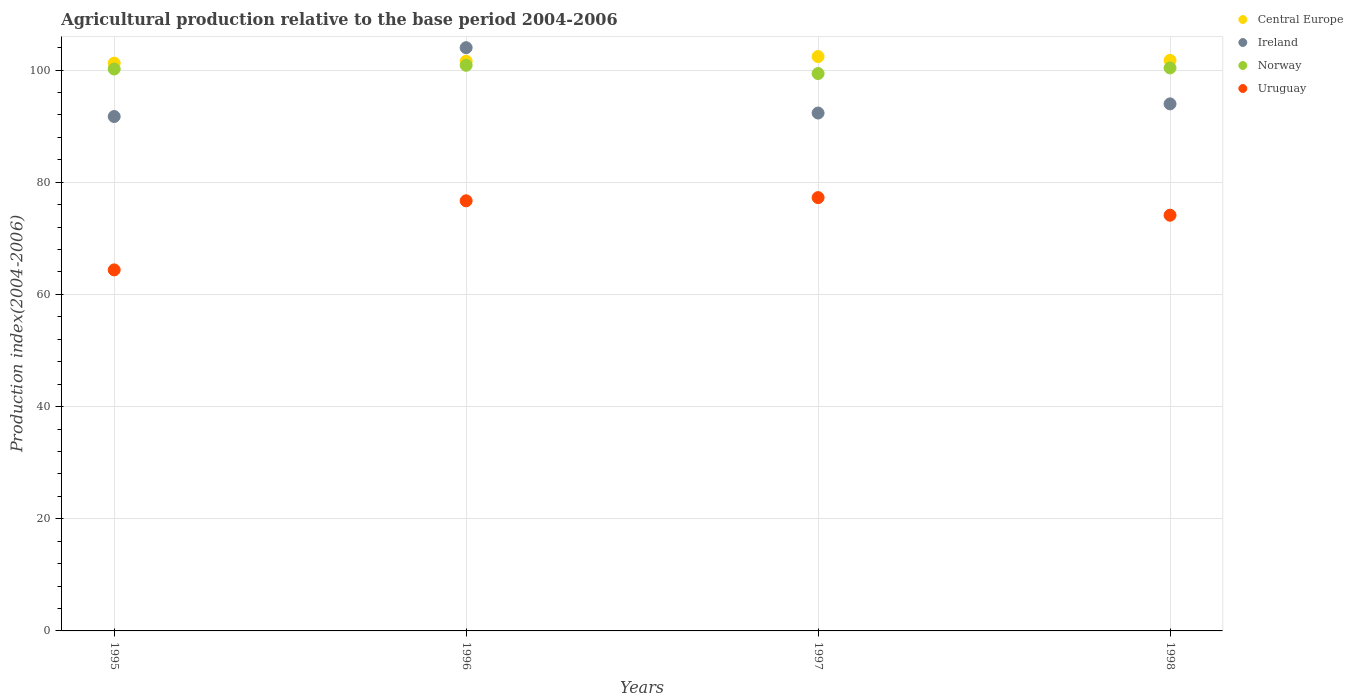Is the number of dotlines equal to the number of legend labels?
Give a very brief answer. Yes. What is the agricultural production index in Ireland in 1995?
Keep it short and to the point. 91.72. Across all years, what is the maximum agricultural production index in Uruguay?
Offer a terse response. 77.26. Across all years, what is the minimum agricultural production index in Uruguay?
Provide a succinct answer. 64.37. In which year was the agricultural production index in Norway maximum?
Your response must be concise. 1996. What is the total agricultural production index in Uruguay in the graph?
Your answer should be compact. 292.44. What is the difference between the agricultural production index in Ireland in 1997 and that in 1998?
Keep it short and to the point. -1.63. What is the difference between the agricultural production index in Ireland in 1998 and the agricultural production index in Uruguay in 1997?
Your answer should be compact. 16.71. What is the average agricultural production index in Central Europe per year?
Make the answer very short. 101.74. In the year 1995, what is the difference between the agricultural production index in Uruguay and agricultural production index in Central Europe?
Provide a short and direct response. -36.86. In how many years, is the agricultural production index in Central Europe greater than 44?
Provide a succinct answer. 4. What is the ratio of the agricultural production index in Uruguay in 1996 to that in 1997?
Your answer should be compact. 0.99. What is the difference between the highest and the second highest agricultural production index in Ireland?
Offer a very short reply. 10.02. What is the difference between the highest and the lowest agricultural production index in Norway?
Give a very brief answer. 1.47. In how many years, is the agricultural production index in Uruguay greater than the average agricultural production index in Uruguay taken over all years?
Give a very brief answer. 3. Does the agricultural production index in Norway monotonically increase over the years?
Your answer should be very brief. No. Is the agricultural production index in Norway strictly greater than the agricultural production index in Ireland over the years?
Ensure brevity in your answer.  No. How many dotlines are there?
Provide a succinct answer. 4. What is the difference between two consecutive major ticks on the Y-axis?
Your answer should be compact. 20. Does the graph contain any zero values?
Offer a very short reply. No. Does the graph contain grids?
Provide a succinct answer. Yes. Where does the legend appear in the graph?
Give a very brief answer. Top right. How are the legend labels stacked?
Your response must be concise. Vertical. What is the title of the graph?
Provide a short and direct response. Agricultural production relative to the base period 2004-2006. Does "Finland" appear as one of the legend labels in the graph?
Make the answer very short. No. What is the label or title of the Y-axis?
Offer a terse response. Production index(2004-2006). What is the Production index(2004-2006) in Central Europe in 1995?
Ensure brevity in your answer.  101.23. What is the Production index(2004-2006) of Ireland in 1995?
Keep it short and to the point. 91.72. What is the Production index(2004-2006) in Norway in 1995?
Provide a short and direct response. 100.19. What is the Production index(2004-2006) in Uruguay in 1995?
Your answer should be compact. 64.37. What is the Production index(2004-2006) of Central Europe in 1996?
Offer a very short reply. 101.58. What is the Production index(2004-2006) in Ireland in 1996?
Keep it short and to the point. 103.99. What is the Production index(2004-2006) of Norway in 1996?
Make the answer very short. 100.85. What is the Production index(2004-2006) of Uruguay in 1996?
Make the answer very short. 76.69. What is the Production index(2004-2006) in Central Europe in 1997?
Keep it short and to the point. 102.41. What is the Production index(2004-2006) of Ireland in 1997?
Your answer should be compact. 92.34. What is the Production index(2004-2006) of Norway in 1997?
Offer a terse response. 99.38. What is the Production index(2004-2006) in Uruguay in 1997?
Offer a very short reply. 77.26. What is the Production index(2004-2006) of Central Europe in 1998?
Keep it short and to the point. 101.72. What is the Production index(2004-2006) of Ireland in 1998?
Give a very brief answer. 93.97. What is the Production index(2004-2006) of Norway in 1998?
Your response must be concise. 100.38. What is the Production index(2004-2006) of Uruguay in 1998?
Keep it short and to the point. 74.12. Across all years, what is the maximum Production index(2004-2006) of Central Europe?
Your response must be concise. 102.41. Across all years, what is the maximum Production index(2004-2006) in Ireland?
Your response must be concise. 103.99. Across all years, what is the maximum Production index(2004-2006) in Norway?
Provide a succinct answer. 100.85. Across all years, what is the maximum Production index(2004-2006) in Uruguay?
Your response must be concise. 77.26. Across all years, what is the minimum Production index(2004-2006) in Central Europe?
Keep it short and to the point. 101.23. Across all years, what is the minimum Production index(2004-2006) in Ireland?
Offer a terse response. 91.72. Across all years, what is the minimum Production index(2004-2006) of Norway?
Give a very brief answer. 99.38. Across all years, what is the minimum Production index(2004-2006) of Uruguay?
Provide a succinct answer. 64.37. What is the total Production index(2004-2006) in Central Europe in the graph?
Provide a short and direct response. 406.95. What is the total Production index(2004-2006) of Ireland in the graph?
Keep it short and to the point. 382.02. What is the total Production index(2004-2006) in Norway in the graph?
Offer a very short reply. 400.8. What is the total Production index(2004-2006) in Uruguay in the graph?
Your response must be concise. 292.44. What is the difference between the Production index(2004-2006) of Central Europe in 1995 and that in 1996?
Your answer should be compact. -0.35. What is the difference between the Production index(2004-2006) of Ireland in 1995 and that in 1996?
Give a very brief answer. -12.27. What is the difference between the Production index(2004-2006) of Norway in 1995 and that in 1996?
Your answer should be compact. -0.66. What is the difference between the Production index(2004-2006) of Uruguay in 1995 and that in 1996?
Make the answer very short. -12.32. What is the difference between the Production index(2004-2006) in Central Europe in 1995 and that in 1997?
Your response must be concise. -1.18. What is the difference between the Production index(2004-2006) of Ireland in 1995 and that in 1997?
Offer a very short reply. -0.62. What is the difference between the Production index(2004-2006) of Norway in 1995 and that in 1997?
Give a very brief answer. 0.81. What is the difference between the Production index(2004-2006) of Uruguay in 1995 and that in 1997?
Offer a terse response. -12.89. What is the difference between the Production index(2004-2006) in Central Europe in 1995 and that in 1998?
Give a very brief answer. -0.49. What is the difference between the Production index(2004-2006) of Ireland in 1995 and that in 1998?
Your answer should be compact. -2.25. What is the difference between the Production index(2004-2006) of Norway in 1995 and that in 1998?
Keep it short and to the point. -0.19. What is the difference between the Production index(2004-2006) of Uruguay in 1995 and that in 1998?
Your answer should be very brief. -9.75. What is the difference between the Production index(2004-2006) of Central Europe in 1996 and that in 1997?
Your answer should be compact. -0.83. What is the difference between the Production index(2004-2006) of Ireland in 1996 and that in 1997?
Make the answer very short. 11.65. What is the difference between the Production index(2004-2006) in Norway in 1996 and that in 1997?
Ensure brevity in your answer.  1.47. What is the difference between the Production index(2004-2006) in Uruguay in 1996 and that in 1997?
Make the answer very short. -0.57. What is the difference between the Production index(2004-2006) of Central Europe in 1996 and that in 1998?
Keep it short and to the point. -0.14. What is the difference between the Production index(2004-2006) of Ireland in 1996 and that in 1998?
Keep it short and to the point. 10.02. What is the difference between the Production index(2004-2006) in Norway in 1996 and that in 1998?
Provide a succinct answer. 0.47. What is the difference between the Production index(2004-2006) in Uruguay in 1996 and that in 1998?
Offer a very short reply. 2.57. What is the difference between the Production index(2004-2006) of Central Europe in 1997 and that in 1998?
Your answer should be compact. 0.69. What is the difference between the Production index(2004-2006) in Ireland in 1997 and that in 1998?
Provide a short and direct response. -1.63. What is the difference between the Production index(2004-2006) of Norway in 1997 and that in 1998?
Keep it short and to the point. -1. What is the difference between the Production index(2004-2006) of Uruguay in 1997 and that in 1998?
Your answer should be compact. 3.14. What is the difference between the Production index(2004-2006) of Central Europe in 1995 and the Production index(2004-2006) of Ireland in 1996?
Offer a terse response. -2.76. What is the difference between the Production index(2004-2006) in Central Europe in 1995 and the Production index(2004-2006) in Norway in 1996?
Your answer should be very brief. 0.38. What is the difference between the Production index(2004-2006) of Central Europe in 1995 and the Production index(2004-2006) of Uruguay in 1996?
Offer a terse response. 24.54. What is the difference between the Production index(2004-2006) in Ireland in 1995 and the Production index(2004-2006) in Norway in 1996?
Give a very brief answer. -9.13. What is the difference between the Production index(2004-2006) in Ireland in 1995 and the Production index(2004-2006) in Uruguay in 1996?
Your answer should be very brief. 15.03. What is the difference between the Production index(2004-2006) of Central Europe in 1995 and the Production index(2004-2006) of Ireland in 1997?
Your answer should be compact. 8.89. What is the difference between the Production index(2004-2006) of Central Europe in 1995 and the Production index(2004-2006) of Norway in 1997?
Your answer should be very brief. 1.85. What is the difference between the Production index(2004-2006) of Central Europe in 1995 and the Production index(2004-2006) of Uruguay in 1997?
Ensure brevity in your answer.  23.97. What is the difference between the Production index(2004-2006) of Ireland in 1995 and the Production index(2004-2006) of Norway in 1997?
Give a very brief answer. -7.66. What is the difference between the Production index(2004-2006) in Ireland in 1995 and the Production index(2004-2006) in Uruguay in 1997?
Offer a very short reply. 14.46. What is the difference between the Production index(2004-2006) in Norway in 1995 and the Production index(2004-2006) in Uruguay in 1997?
Make the answer very short. 22.93. What is the difference between the Production index(2004-2006) in Central Europe in 1995 and the Production index(2004-2006) in Ireland in 1998?
Your answer should be compact. 7.26. What is the difference between the Production index(2004-2006) of Central Europe in 1995 and the Production index(2004-2006) of Norway in 1998?
Your response must be concise. 0.85. What is the difference between the Production index(2004-2006) of Central Europe in 1995 and the Production index(2004-2006) of Uruguay in 1998?
Give a very brief answer. 27.11. What is the difference between the Production index(2004-2006) of Ireland in 1995 and the Production index(2004-2006) of Norway in 1998?
Offer a terse response. -8.66. What is the difference between the Production index(2004-2006) in Norway in 1995 and the Production index(2004-2006) in Uruguay in 1998?
Give a very brief answer. 26.07. What is the difference between the Production index(2004-2006) in Central Europe in 1996 and the Production index(2004-2006) in Ireland in 1997?
Provide a succinct answer. 9.24. What is the difference between the Production index(2004-2006) of Central Europe in 1996 and the Production index(2004-2006) of Norway in 1997?
Your answer should be compact. 2.2. What is the difference between the Production index(2004-2006) in Central Europe in 1996 and the Production index(2004-2006) in Uruguay in 1997?
Offer a very short reply. 24.32. What is the difference between the Production index(2004-2006) of Ireland in 1996 and the Production index(2004-2006) of Norway in 1997?
Keep it short and to the point. 4.61. What is the difference between the Production index(2004-2006) of Ireland in 1996 and the Production index(2004-2006) of Uruguay in 1997?
Make the answer very short. 26.73. What is the difference between the Production index(2004-2006) in Norway in 1996 and the Production index(2004-2006) in Uruguay in 1997?
Your answer should be very brief. 23.59. What is the difference between the Production index(2004-2006) in Central Europe in 1996 and the Production index(2004-2006) in Ireland in 1998?
Offer a terse response. 7.61. What is the difference between the Production index(2004-2006) in Central Europe in 1996 and the Production index(2004-2006) in Norway in 1998?
Provide a succinct answer. 1.2. What is the difference between the Production index(2004-2006) in Central Europe in 1996 and the Production index(2004-2006) in Uruguay in 1998?
Make the answer very short. 27.46. What is the difference between the Production index(2004-2006) of Ireland in 1996 and the Production index(2004-2006) of Norway in 1998?
Your response must be concise. 3.61. What is the difference between the Production index(2004-2006) in Ireland in 1996 and the Production index(2004-2006) in Uruguay in 1998?
Your answer should be compact. 29.87. What is the difference between the Production index(2004-2006) of Norway in 1996 and the Production index(2004-2006) of Uruguay in 1998?
Your answer should be very brief. 26.73. What is the difference between the Production index(2004-2006) in Central Europe in 1997 and the Production index(2004-2006) in Ireland in 1998?
Give a very brief answer. 8.44. What is the difference between the Production index(2004-2006) in Central Europe in 1997 and the Production index(2004-2006) in Norway in 1998?
Make the answer very short. 2.03. What is the difference between the Production index(2004-2006) in Central Europe in 1997 and the Production index(2004-2006) in Uruguay in 1998?
Your response must be concise. 28.29. What is the difference between the Production index(2004-2006) of Ireland in 1997 and the Production index(2004-2006) of Norway in 1998?
Your response must be concise. -8.04. What is the difference between the Production index(2004-2006) in Ireland in 1997 and the Production index(2004-2006) in Uruguay in 1998?
Offer a terse response. 18.22. What is the difference between the Production index(2004-2006) in Norway in 1997 and the Production index(2004-2006) in Uruguay in 1998?
Offer a terse response. 25.26. What is the average Production index(2004-2006) in Central Europe per year?
Offer a very short reply. 101.74. What is the average Production index(2004-2006) in Ireland per year?
Offer a very short reply. 95.5. What is the average Production index(2004-2006) of Norway per year?
Offer a very short reply. 100.2. What is the average Production index(2004-2006) in Uruguay per year?
Offer a very short reply. 73.11. In the year 1995, what is the difference between the Production index(2004-2006) in Central Europe and Production index(2004-2006) in Ireland?
Your answer should be compact. 9.51. In the year 1995, what is the difference between the Production index(2004-2006) of Central Europe and Production index(2004-2006) of Norway?
Your response must be concise. 1.04. In the year 1995, what is the difference between the Production index(2004-2006) of Central Europe and Production index(2004-2006) of Uruguay?
Offer a terse response. 36.86. In the year 1995, what is the difference between the Production index(2004-2006) in Ireland and Production index(2004-2006) in Norway?
Provide a succinct answer. -8.47. In the year 1995, what is the difference between the Production index(2004-2006) in Ireland and Production index(2004-2006) in Uruguay?
Provide a succinct answer. 27.35. In the year 1995, what is the difference between the Production index(2004-2006) in Norway and Production index(2004-2006) in Uruguay?
Offer a terse response. 35.82. In the year 1996, what is the difference between the Production index(2004-2006) in Central Europe and Production index(2004-2006) in Ireland?
Make the answer very short. -2.41. In the year 1996, what is the difference between the Production index(2004-2006) in Central Europe and Production index(2004-2006) in Norway?
Give a very brief answer. 0.73. In the year 1996, what is the difference between the Production index(2004-2006) in Central Europe and Production index(2004-2006) in Uruguay?
Provide a succinct answer. 24.89. In the year 1996, what is the difference between the Production index(2004-2006) of Ireland and Production index(2004-2006) of Norway?
Your response must be concise. 3.14. In the year 1996, what is the difference between the Production index(2004-2006) in Ireland and Production index(2004-2006) in Uruguay?
Provide a succinct answer. 27.3. In the year 1996, what is the difference between the Production index(2004-2006) of Norway and Production index(2004-2006) of Uruguay?
Your answer should be very brief. 24.16. In the year 1997, what is the difference between the Production index(2004-2006) in Central Europe and Production index(2004-2006) in Ireland?
Provide a short and direct response. 10.07. In the year 1997, what is the difference between the Production index(2004-2006) of Central Europe and Production index(2004-2006) of Norway?
Your response must be concise. 3.03. In the year 1997, what is the difference between the Production index(2004-2006) of Central Europe and Production index(2004-2006) of Uruguay?
Keep it short and to the point. 25.15. In the year 1997, what is the difference between the Production index(2004-2006) of Ireland and Production index(2004-2006) of Norway?
Provide a succinct answer. -7.04. In the year 1997, what is the difference between the Production index(2004-2006) in Ireland and Production index(2004-2006) in Uruguay?
Your answer should be compact. 15.08. In the year 1997, what is the difference between the Production index(2004-2006) of Norway and Production index(2004-2006) of Uruguay?
Your response must be concise. 22.12. In the year 1998, what is the difference between the Production index(2004-2006) of Central Europe and Production index(2004-2006) of Ireland?
Your response must be concise. 7.75. In the year 1998, what is the difference between the Production index(2004-2006) of Central Europe and Production index(2004-2006) of Norway?
Your answer should be compact. 1.34. In the year 1998, what is the difference between the Production index(2004-2006) in Central Europe and Production index(2004-2006) in Uruguay?
Offer a very short reply. 27.6. In the year 1998, what is the difference between the Production index(2004-2006) of Ireland and Production index(2004-2006) of Norway?
Give a very brief answer. -6.41. In the year 1998, what is the difference between the Production index(2004-2006) in Ireland and Production index(2004-2006) in Uruguay?
Your answer should be very brief. 19.85. In the year 1998, what is the difference between the Production index(2004-2006) of Norway and Production index(2004-2006) of Uruguay?
Keep it short and to the point. 26.26. What is the ratio of the Production index(2004-2006) in Ireland in 1995 to that in 1996?
Make the answer very short. 0.88. What is the ratio of the Production index(2004-2006) in Norway in 1995 to that in 1996?
Ensure brevity in your answer.  0.99. What is the ratio of the Production index(2004-2006) in Uruguay in 1995 to that in 1996?
Offer a terse response. 0.84. What is the ratio of the Production index(2004-2006) in Central Europe in 1995 to that in 1997?
Provide a succinct answer. 0.99. What is the ratio of the Production index(2004-2006) in Norway in 1995 to that in 1997?
Offer a terse response. 1.01. What is the ratio of the Production index(2004-2006) of Uruguay in 1995 to that in 1997?
Your answer should be compact. 0.83. What is the ratio of the Production index(2004-2006) in Ireland in 1995 to that in 1998?
Your response must be concise. 0.98. What is the ratio of the Production index(2004-2006) of Norway in 1995 to that in 1998?
Ensure brevity in your answer.  1. What is the ratio of the Production index(2004-2006) of Uruguay in 1995 to that in 1998?
Offer a very short reply. 0.87. What is the ratio of the Production index(2004-2006) in Central Europe in 1996 to that in 1997?
Ensure brevity in your answer.  0.99. What is the ratio of the Production index(2004-2006) in Ireland in 1996 to that in 1997?
Give a very brief answer. 1.13. What is the ratio of the Production index(2004-2006) of Norway in 1996 to that in 1997?
Give a very brief answer. 1.01. What is the ratio of the Production index(2004-2006) in Ireland in 1996 to that in 1998?
Provide a succinct answer. 1.11. What is the ratio of the Production index(2004-2006) in Uruguay in 1996 to that in 1998?
Your response must be concise. 1.03. What is the ratio of the Production index(2004-2006) in Ireland in 1997 to that in 1998?
Make the answer very short. 0.98. What is the ratio of the Production index(2004-2006) in Uruguay in 1997 to that in 1998?
Offer a very short reply. 1.04. What is the difference between the highest and the second highest Production index(2004-2006) of Central Europe?
Your response must be concise. 0.69. What is the difference between the highest and the second highest Production index(2004-2006) of Ireland?
Keep it short and to the point. 10.02. What is the difference between the highest and the second highest Production index(2004-2006) of Norway?
Give a very brief answer. 0.47. What is the difference between the highest and the second highest Production index(2004-2006) of Uruguay?
Keep it short and to the point. 0.57. What is the difference between the highest and the lowest Production index(2004-2006) of Central Europe?
Provide a short and direct response. 1.18. What is the difference between the highest and the lowest Production index(2004-2006) in Ireland?
Your response must be concise. 12.27. What is the difference between the highest and the lowest Production index(2004-2006) of Norway?
Your response must be concise. 1.47. What is the difference between the highest and the lowest Production index(2004-2006) in Uruguay?
Provide a succinct answer. 12.89. 